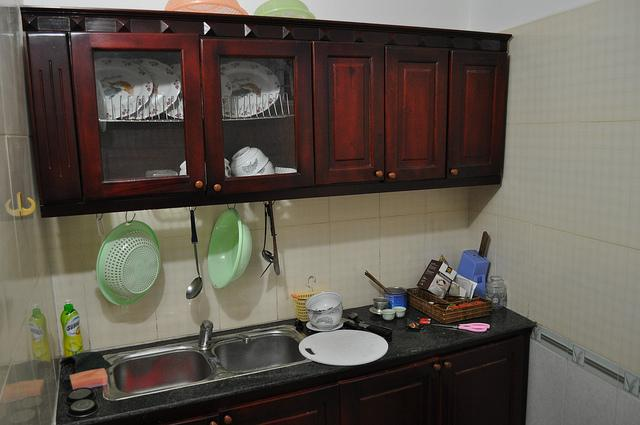What color are the noodle strainers hanging underneath of the cupboard and above the sink? green 